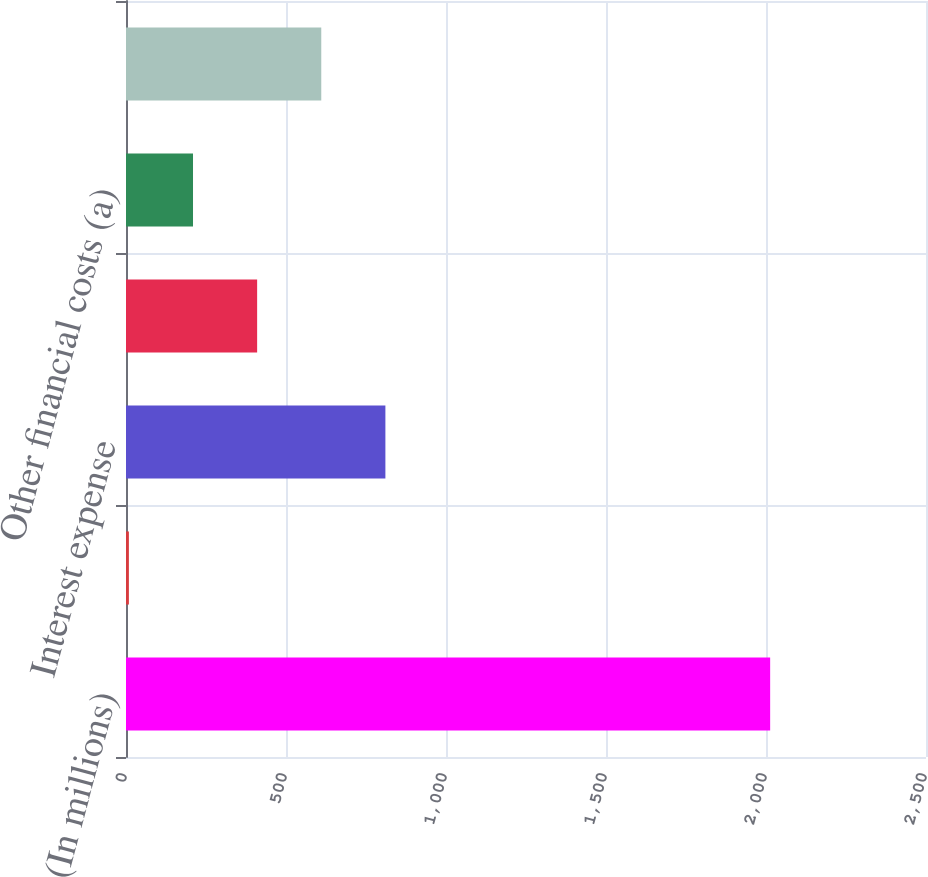Convert chart to OTSL. <chart><loc_0><loc_0><loc_500><loc_500><bar_chart><fcel>(In millions)<fcel>Interest income<fcel>Interest expense<fcel>Interest capitalized<fcel>Other financial costs (a)<fcel>Net interest and other<nl><fcel>2013<fcel>9<fcel>810.6<fcel>409.8<fcel>209.4<fcel>610.2<nl></chart> 